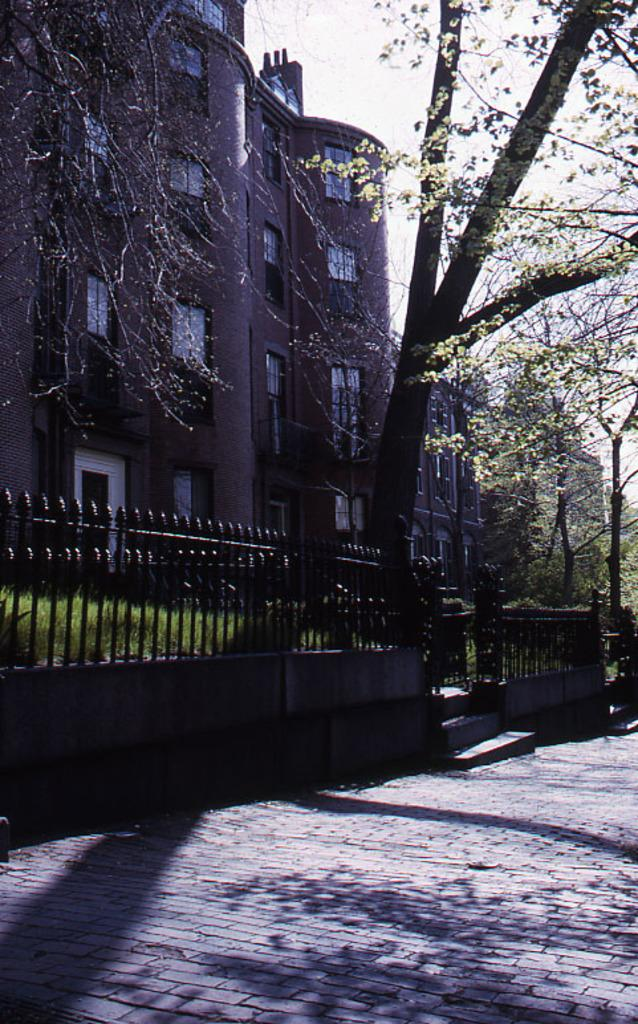What is the main feature of the image? There is a road in the image. What is located next to the road? There is a railing next to the road. What type of vegetation is visible near the road? Grass is visible next to the road. How many trees can be seen in the image? There are many trees in the image. What can be seen in the background of the image? There is a building with windows and the sky is visible in the background. How many feet does the snake have in the image? There is no snake present in the image. Who is the creator of the road in the image? The image does not provide information about the creator of the road. 